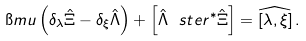Convert formula to latex. <formula><loc_0><loc_0><loc_500><loc_500>\i m u \left ( { \delta } _ { \lambda } { \hat { \Xi } } - { \delta } _ { \xi } { \hat { \Lambda } } \right ) + \left [ { \hat { \Lambda } } \ s t e r { ^ { * } } { \hat { \Xi } } \right ] = \widehat { \left [ \lambda , \xi \right ] } \, .</formula> 